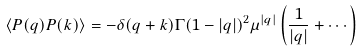<formula> <loc_0><loc_0><loc_500><loc_500>\langle P ( q ) P ( k ) \rangle = - \delta ( q + k ) \Gamma ( 1 - | q | ) ^ { 2 } \mu ^ { | q | } \left ( \frac { 1 } { | q | } + \cdots \right )</formula> 